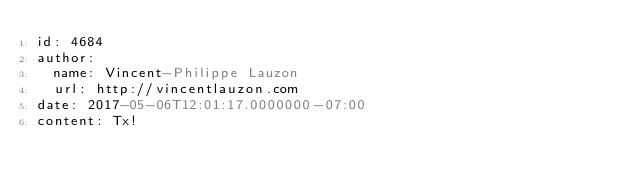Convert code to text. <code><loc_0><loc_0><loc_500><loc_500><_YAML_>id: 4684
author:
  name: Vincent-Philippe Lauzon
  url: http://vincentlauzon.com
date: 2017-05-06T12:01:17.0000000-07:00
content: Tx!
</code> 